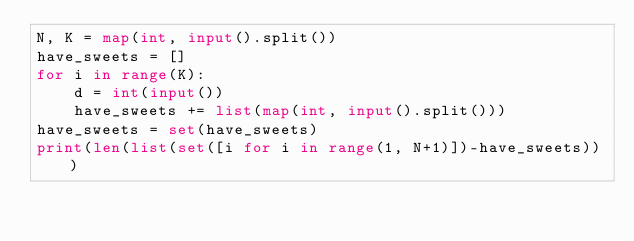<code> <loc_0><loc_0><loc_500><loc_500><_Python_>N, K = map(int, input().split())
have_sweets = []
for i in range(K):
    d = int(input())
    have_sweets += list(map(int, input().split()))
have_sweets = set(have_sweets)
print(len(list(set([i for i in range(1, N+1)])-have_sweets)))
</code> 